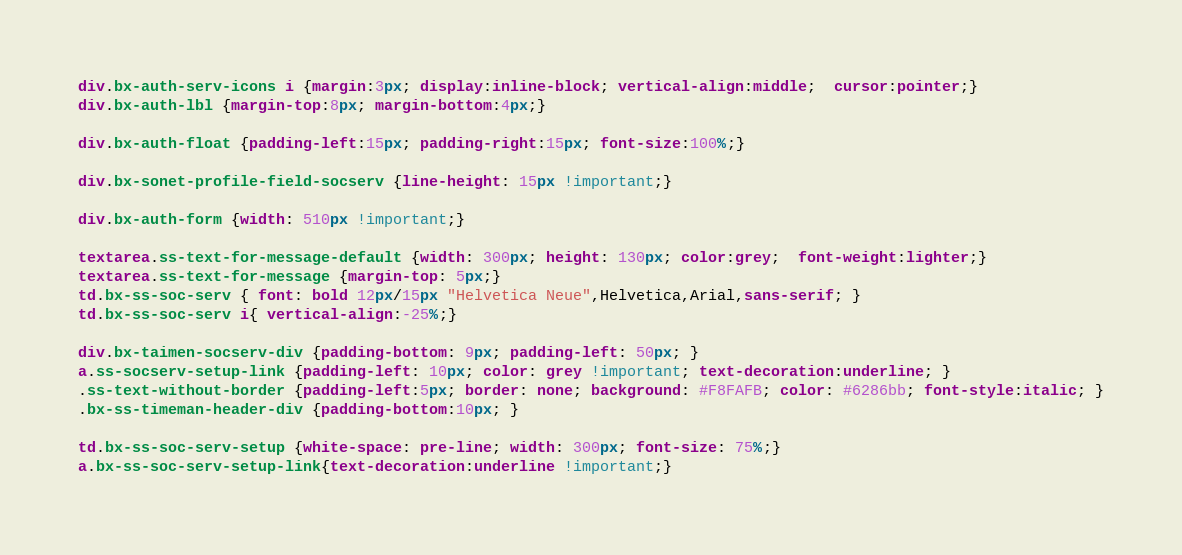Convert code to text. <code><loc_0><loc_0><loc_500><loc_500><_CSS_>div.bx-auth-serv-icons i {margin:3px; display:inline-block; vertical-align:middle;  cursor:pointer;}
div.bx-auth-lbl {margin-top:8px; margin-bottom:4px;}

div.bx-auth-float {padding-left:15px; padding-right:15px; font-size:100%;}

div.bx-sonet-profile-field-socserv {line-height: 15px !important;}

div.bx-auth-form {width: 510px !important;}

textarea.ss-text-for-message-default {width: 300px; height: 130px; color:grey;  font-weight:lighter;}
textarea.ss-text-for-message {margin-top: 5px;}
td.bx-ss-soc-serv { font: bold 12px/15px "Helvetica Neue",Helvetica,Arial,sans-serif; }
td.bx-ss-soc-serv i{ vertical-align:-25%;}

div.bx-taimen-socserv-div {padding-bottom: 9px; padding-left: 50px; }
a.ss-socserv-setup-link {padding-left: 10px; color: grey !important; text-decoration:underline; }
.ss-text-without-border {padding-left:5px; border: none; background: #F8FAFB; color: #6286bb; font-style:italic; }
.bx-ss-timeman-header-div {padding-bottom:10px; }

td.bx-ss-soc-serv-setup {white-space: pre-line; width: 300px; font-size: 75%;}
a.bx-ss-soc-serv-setup-link{text-decoration:underline !important;}</code> 